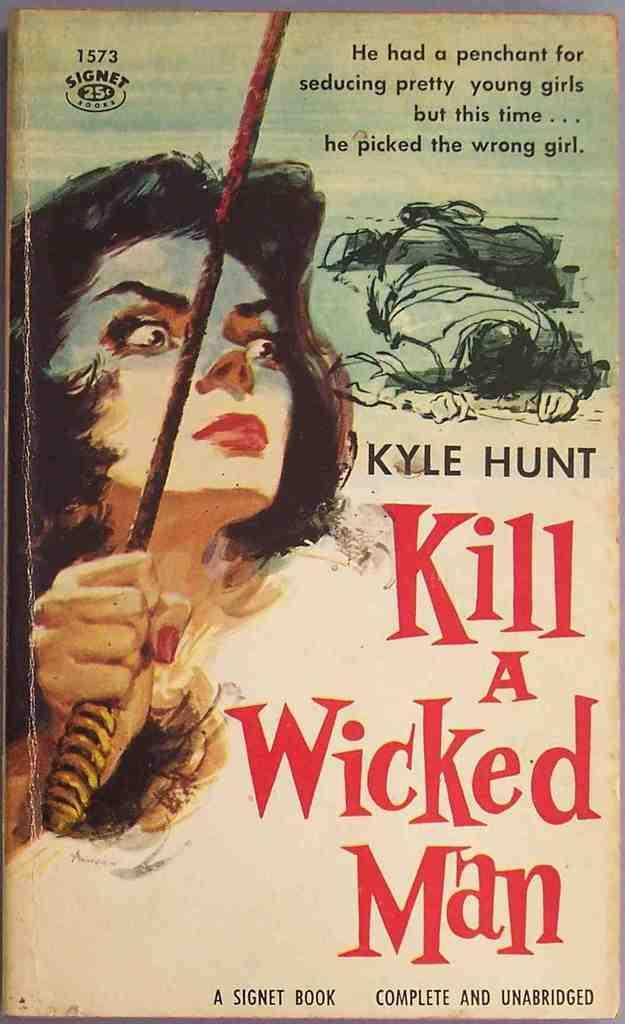What is present in the image? There is a poster in the image. What is depicted on the poster? The poster features a woman. What is the woman doing in the image? The woman is holding an object in her hand. How many dogs are present in the image? There are no dogs present in the image; it only features a poster with a woman holding an object. What month is it in the image? The month is not mentioned or depicted in the image, as it only features a poster with a woman holding an object. 